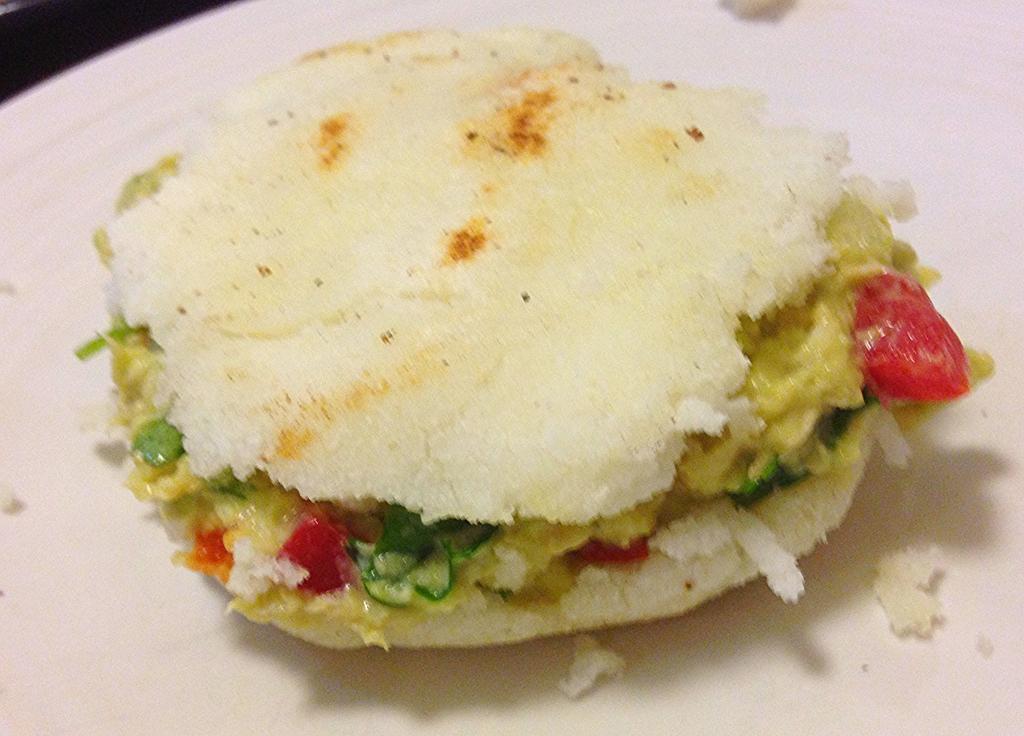Could you give a brief overview of what you see in this image? This image contains a plate having breasts stuffed with some food in it. 